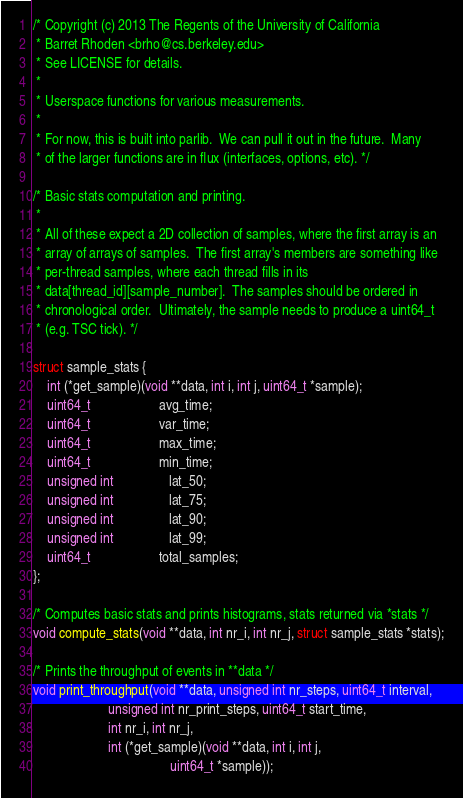Convert code to text. <code><loc_0><loc_0><loc_500><loc_500><_C_>/* Copyright (c) 2013 The Regents of the University of California
 * Barret Rhoden <brho@cs.berkeley.edu>
 * See LICENSE for details.
 *
 * Userspace functions for various measurements.
 *
 * For now, this is built into parlib.  We can pull it out in the future.  Many
 * of the larger functions are in flux (interfaces, options, etc). */

/* Basic stats computation and printing.
 *
 * All of these expect a 2D collection of samples, where the first array is an
 * array of arrays of samples.  The first array's members are something like
 * per-thread samples, where each thread fills in its
 * data[thread_id][sample_number].  The samples should be ordered in
 * chronological order.  Ultimately, the sample needs to produce a uint64_t
 * (e.g. TSC tick). */

struct sample_stats {
	int (*get_sample)(void **data, int i, int j, uint64_t *sample);
	uint64_t					avg_time;
	uint64_t					var_time;
	uint64_t					max_time;
	uint64_t					min_time;
	unsigned int				lat_50;
	unsigned int				lat_75;
	unsigned int				lat_90;
	unsigned int				lat_99;
	uint64_t					total_samples;
};

/* Computes basic stats and prints histograms, stats returned via *stats */
void compute_stats(void **data, int nr_i, int nr_j, struct sample_stats *stats);

/* Prints the throughput of events in **data */
void print_throughput(void **data, unsigned int nr_steps, uint64_t interval,
                      unsigned int nr_print_steps, uint64_t start_time,
                      int nr_i, int nr_j,
                      int (*get_sample)(void **data, int i, int j,
                                        uint64_t *sample));
</code> 